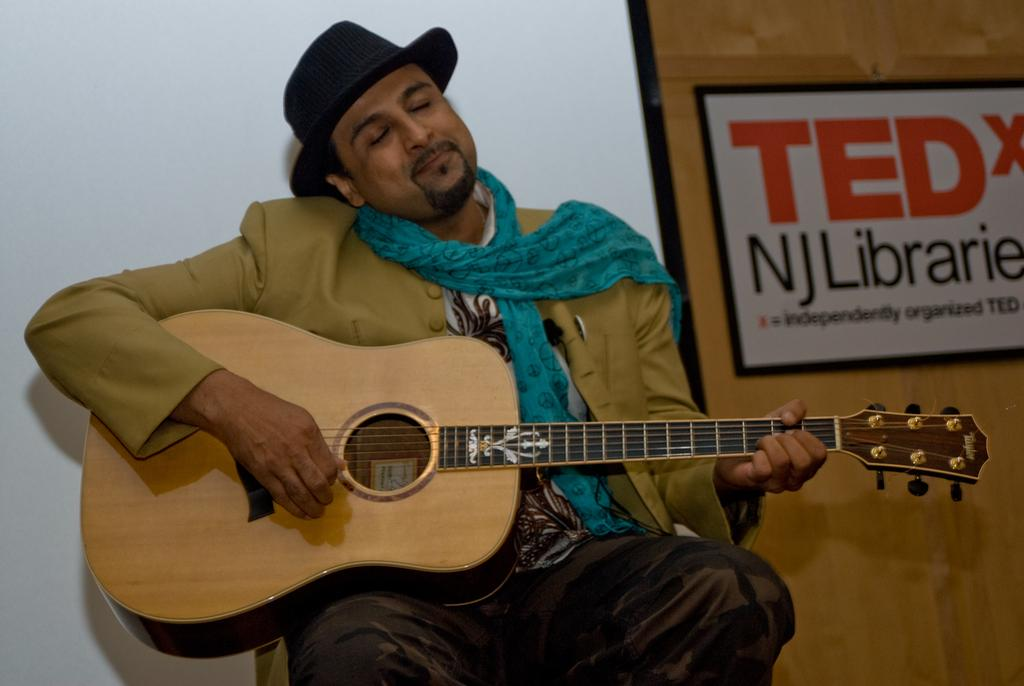What is the person in the image doing? The person is sitting in the image. What object is the person holding? The person is holding a guitar. Can you describe the person's attire? The person is wearing a cap. What can be seen in the background of the image? There is a wall in the background of the image. What is on the wall in the background? There is a poster on the wall in the background. What type of mass can be seen growing in the garden in the image? There is no garden present in the image, so it is not possible to determine if there is any mass growing in it. 